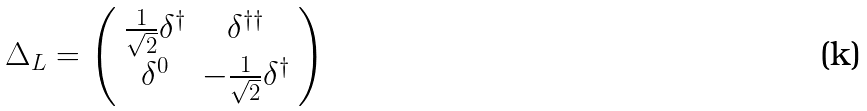<formula> <loc_0><loc_0><loc_500><loc_500>\Delta _ { L } = \left ( \begin{array} { c c } \frac { 1 } { \sqrt { 2 } } \delta ^ { \dagger } & \delta ^ { \dagger \dagger } \\ \delta ^ { 0 } & - \frac { 1 } { \sqrt { 2 } } \delta ^ { \dagger } \end{array} \right )</formula> 